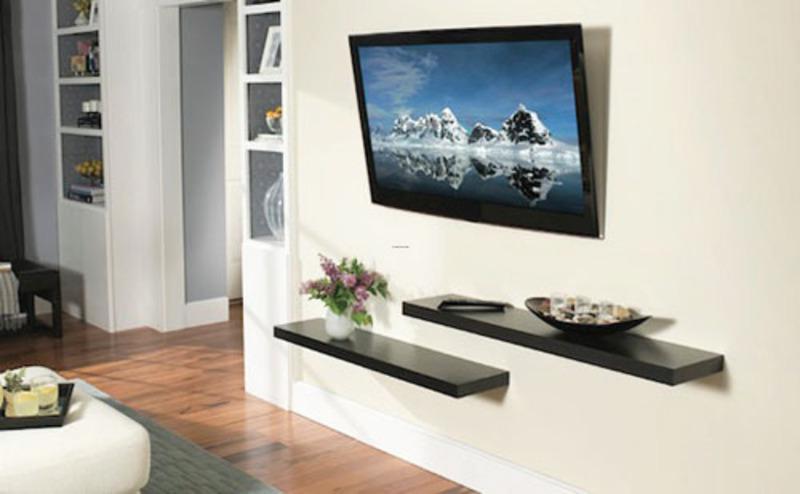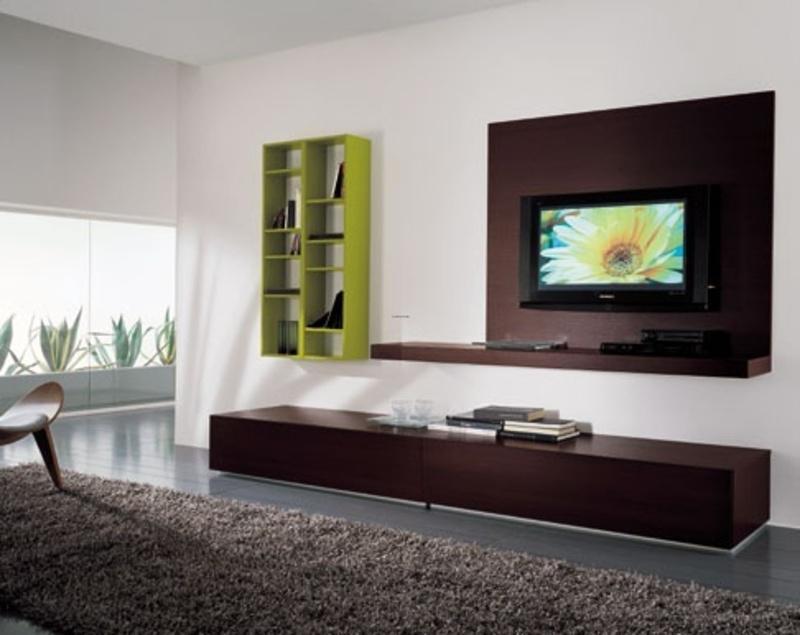The first image is the image on the left, the second image is the image on the right. Evaluate the accuracy of this statement regarding the images: "At least one television is on.". Is it true? Answer yes or no. Yes. The first image is the image on the left, the second image is the image on the right. Assess this claim about the two images: "In at least one image there is a TV mounted to a shelf with a tall back over a long cabinet.". Correct or not? Answer yes or no. Yes. 